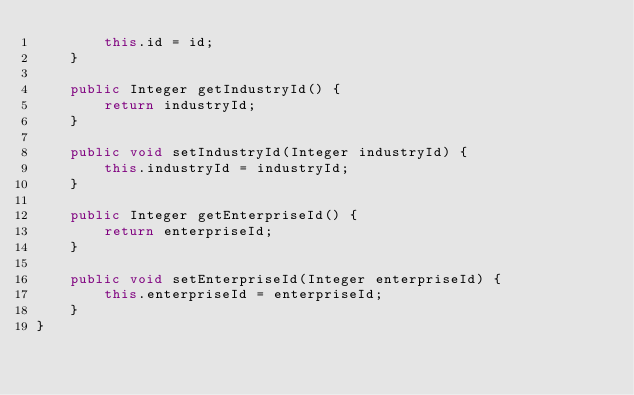Convert code to text. <code><loc_0><loc_0><loc_500><loc_500><_Java_>        this.id = id;
    }

    public Integer getIndustryId() {
        return industryId;
    }

    public void setIndustryId(Integer industryId) {
        this.industryId = industryId;
    }

    public Integer getEnterpriseId() {
        return enterpriseId;
    }

    public void setEnterpriseId(Integer enterpriseId) {
        this.enterpriseId = enterpriseId;
    }
}</code> 